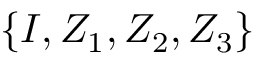<formula> <loc_0><loc_0><loc_500><loc_500>\{ I , Z _ { 1 } , Z _ { 2 } , Z _ { 3 } \}</formula> 